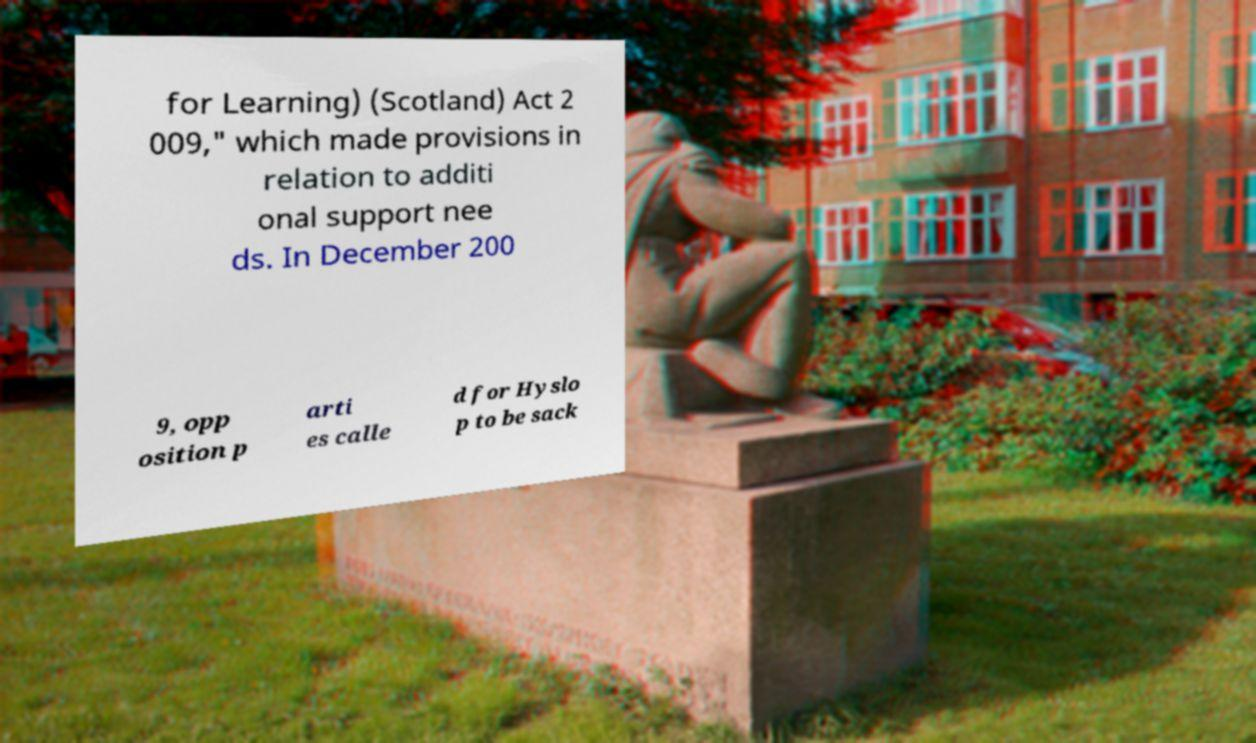Can you read and provide the text displayed in the image?This photo seems to have some interesting text. Can you extract and type it out for me? for Learning) (Scotland) Act 2 009," which made provisions in relation to additi onal support nee ds. In December 200 9, opp osition p arti es calle d for Hyslo p to be sack 